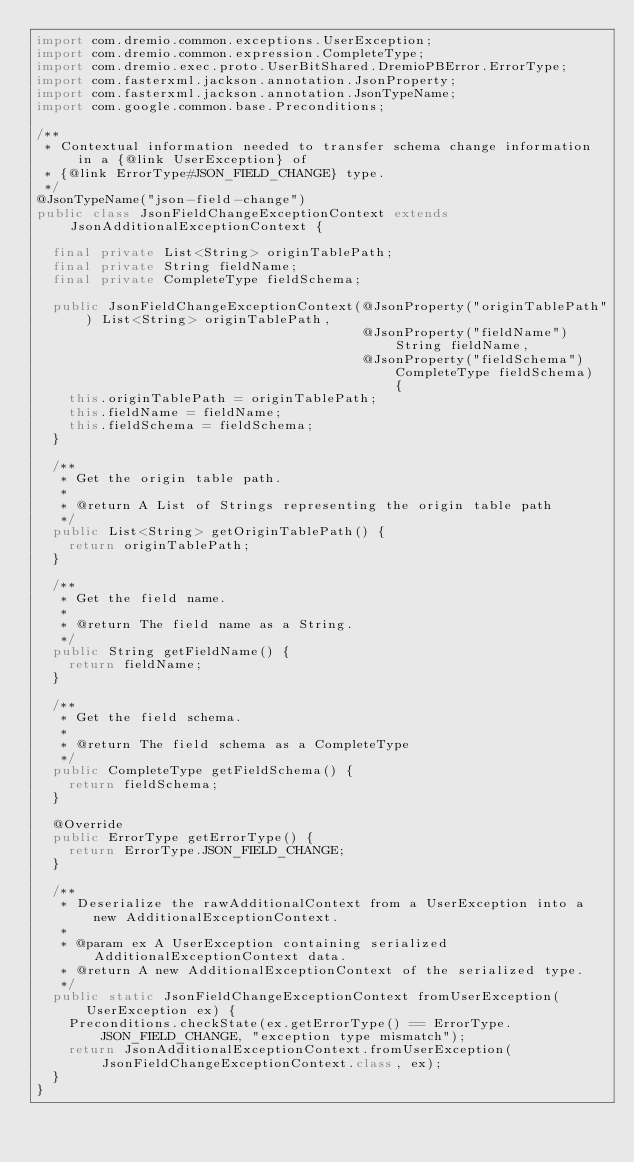Convert code to text. <code><loc_0><loc_0><loc_500><loc_500><_Java_>import com.dremio.common.exceptions.UserException;
import com.dremio.common.expression.CompleteType;
import com.dremio.exec.proto.UserBitShared.DremioPBError.ErrorType;
import com.fasterxml.jackson.annotation.JsonProperty;
import com.fasterxml.jackson.annotation.JsonTypeName;
import com.google.common.base.Preconditions;

/**
 * Contextual information needed to transfer schema change information in a {@link UserException} of
 * {@link ErrorType#JSON_FIELD_CHANGE} type.
 */
@JsonTypeName("json-field-change")
public class JsonFieldChangeExceptionContext extends JsonAdditionalExceptionContext {

  final private List<String> originTablePath;
  final private String fieldName;
  final private CompleteType fieldSchema;

  public JsonFieldChangeExceptionContext(@JsonProperty("originTablePath") List<String> originTablePath,
                                         @JsonProperty("fieldName") String fieldName,
                                         @JsonProperty("fieldSchema") CompleteType fieldSchema) {
    this.originTablePath = originTablePath;
    this.fieldName = fieldName;
    this.fieldSchema = fieldSchema;
  }

  /**
   * Get the origin table path.
   *
   * @return A List of Strings representing the origin table path
   */
  public List<String> getOriginTablePath() {
    return originTablePath;
  }

  /**
   * Get the field name.
   *
   * @return The field name as a String.
   */
  public String getFieldName() {
    return fieldName;
  }

  /**
   * Get the field schema.
   *
   * @return The field schema as a CompleteType
   */
  public CompleteType getFieldSchema() {
    return fieldSchema;
  }

  @Override
  public ErrorType getErrorType() {
    return ErrorType.JSON_FIELD_CHANGE;
  }

  /**
   * Deserialize the rawAdditionalContext from a UserException into a new AdditionalExceptionContext.
   *
   * @param ex A UserException containing serialized AdditionalExceptionContext data.
   * @return A new AdditionalExceptionContext of the serialized type.
   */
  public static JsonFieldChangeExceptionContext fromUserException(UserException ex) {
    Preconditions.checkState(ex.getErrorType() == ErrorType.JSON_FIELD_CHANGE, "exception type mismatch");
    return JsonAdditionalExceptionContext.fromUserException(JsonFieldChangeExceptionContext.class, ex);
  }
}
</code> 